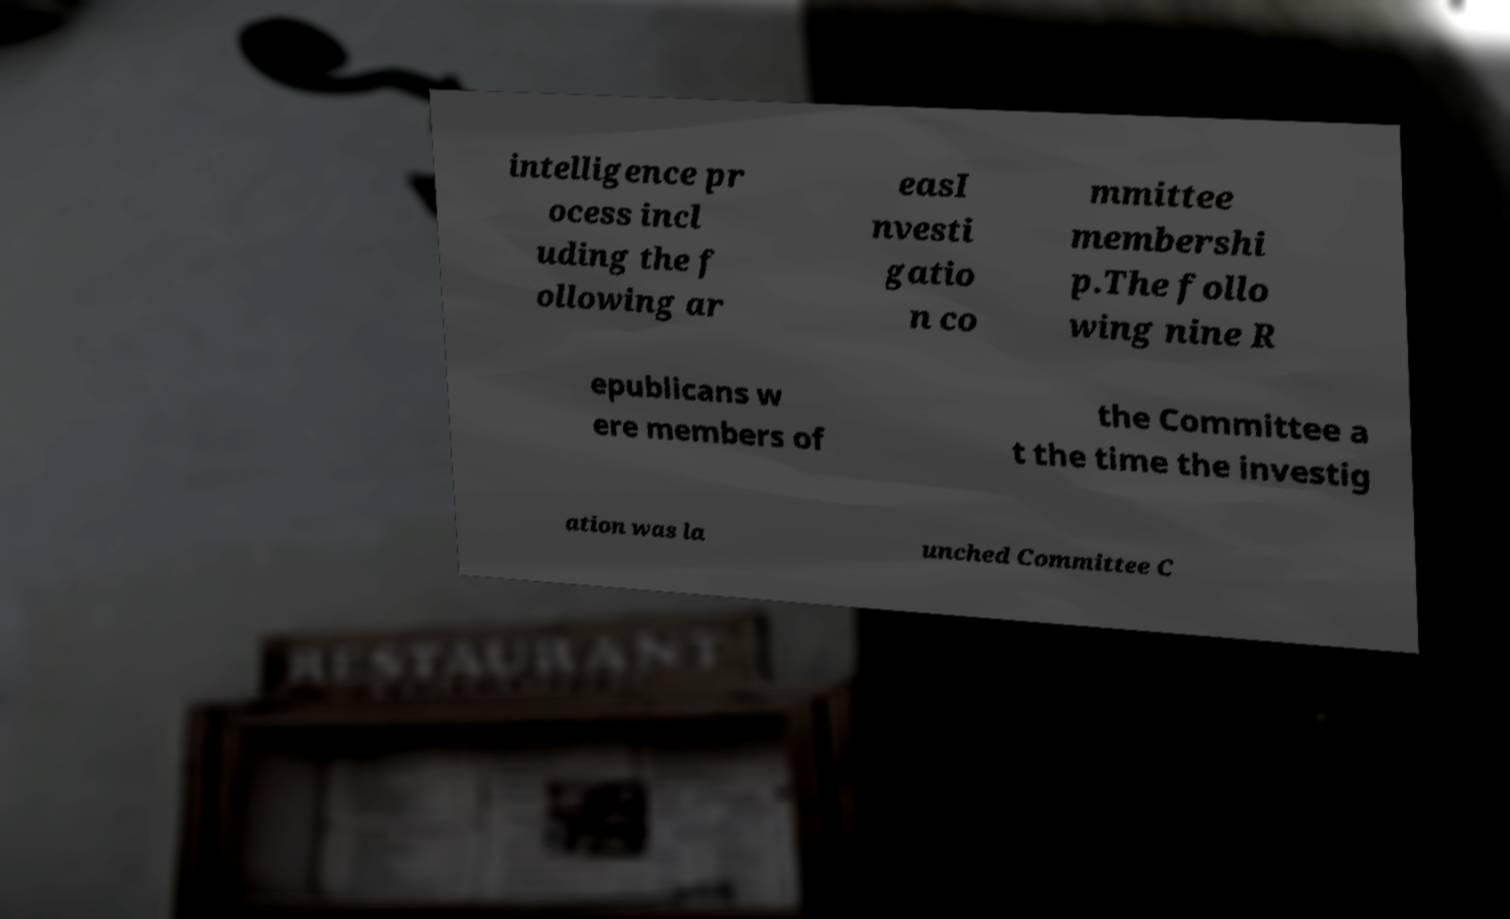I need the written content from this picture converted into text. Can you do that? intelligence pr ocess incl uding the f ollowing ar easI nvesti gatio n co mmittee membershi p.The follo wing nine R epublicans w ere members of the Committee a t the time the investig ation was la unched Committee C 